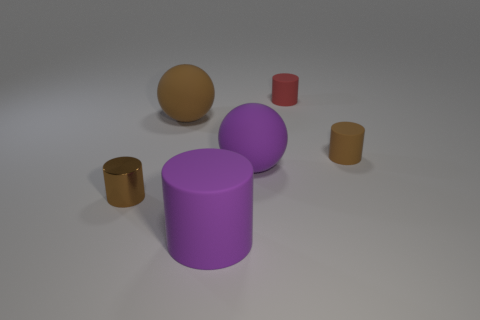How many objects are right of the tiny shiny thing to the left of the purple thing right of the purple rubber cylinder?
Give a very brief answer. 5. What color is the large rubber thing that is the same shape as the tiny brown shiny object?
Offer a terse response. Purple. Is there any other thing that is the same shape as the small brown metallic object?
Your answer should be very brief. Yes. How many cylinders are small brown objects or red things?
Give a very brief answer. 3. What is the shape of the small brown metallic thing?
Your answer should be very brief. Cylinder. Are there any large brown objects in front of the purple rubber cylinder?
Provide a short and direct response. No. Are the large purple ball and the large object that is behind the small brown matte thing made of the same material?
Your answer should be compact. Yes. Do the small brown object to the left of the tiny brown matte object and the big brown matte thing have the same shape?
Keep it short and to the point. No. How many other red cylinders have the same material as the small red cylinder?
Offer a terse response. 0. What number of objects are either tiny objects right of the small red cylinder or shiny cylinders?
Your answer should be very brief. 2. 